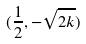<formula> <loc_0><loc_0><loc_500><loc_500>( \frac { 1 } { 2 } , - \sqrt { 2 k } )</formula> 